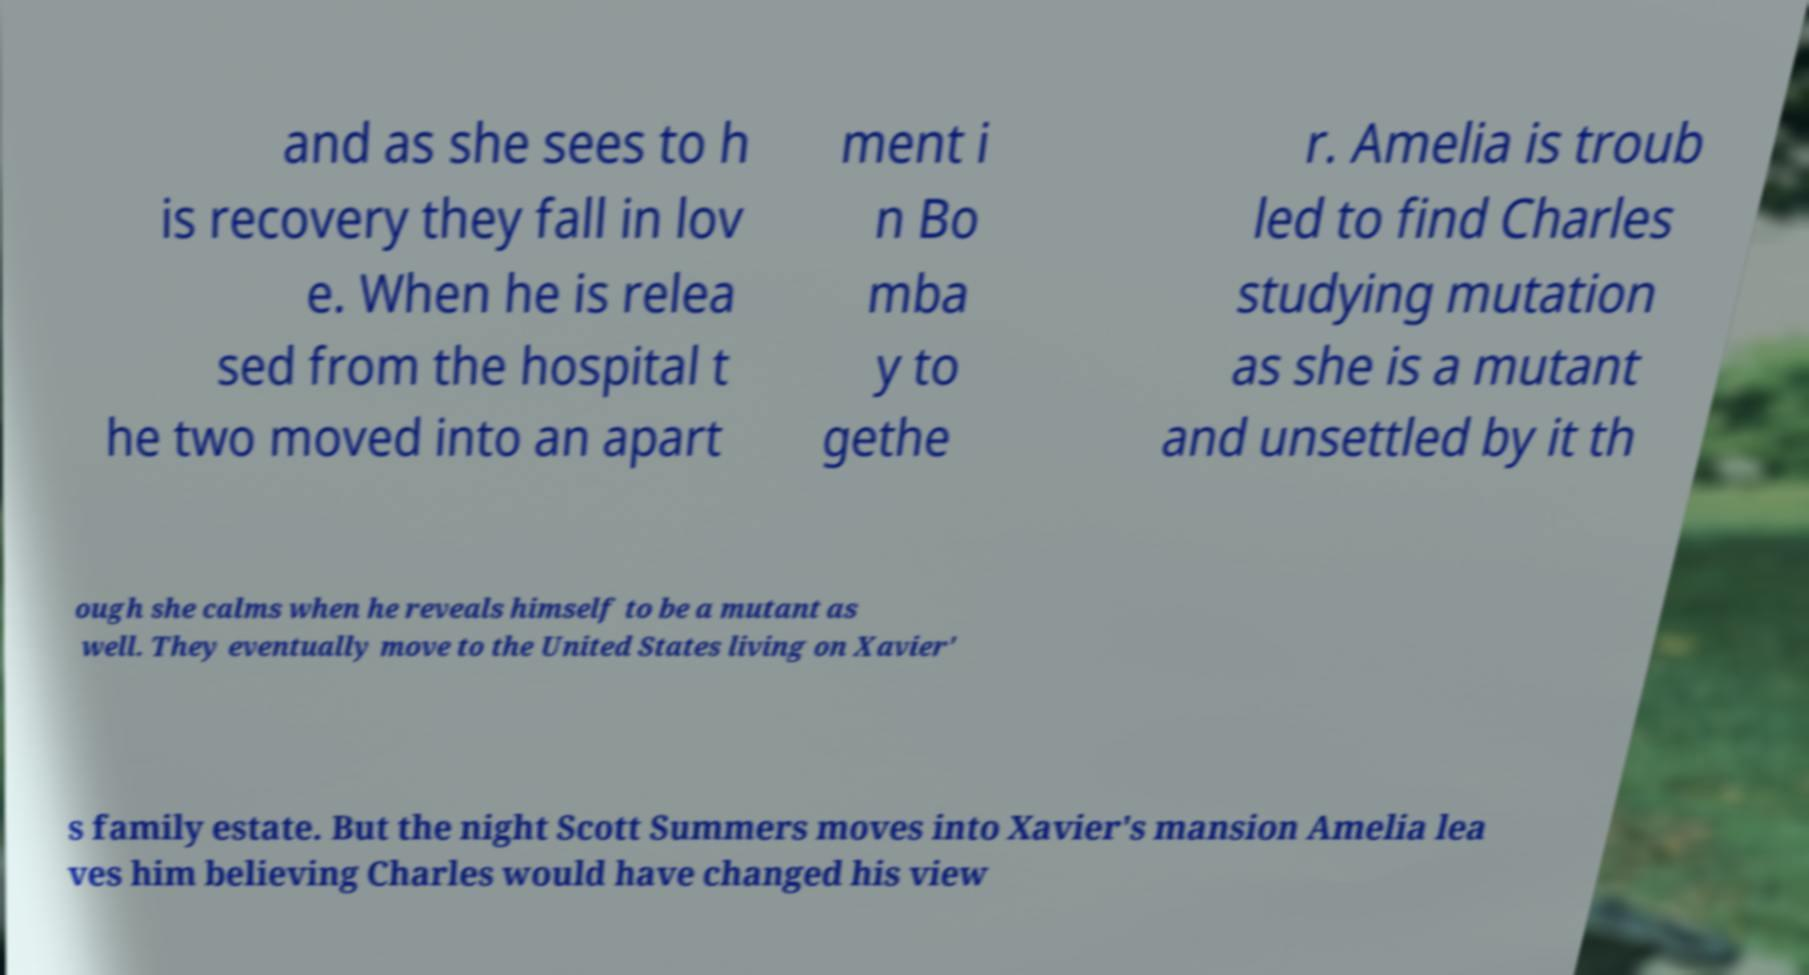For documentation purposes, I need the text within this image transcribed. Could you provide that? and as she sees to h is recovery they fall in lov e. When he is relea sed from the hospital t he two moved into an apart ment i n Bo mba y to gethe r. Amelia is troub led to find Charles studying mutation as she is a mutant and unsettled by it th ough she calms when he reveals himself to be a mutant as well. They eventually move to the United States living on Xavier' s family estate. But the night Scott Summers moves into Xavier's mansion Amelia lea ves him believing Charles would have changed his view 